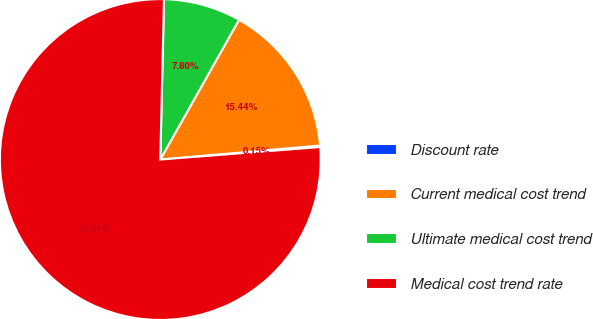Convert chart. <chart><loc_0><loc_0><loc_500><loc_500><pie_chart><fcel>Discount rate<fcel>Current medical cost trend<fcel>Ultimate medical cost trend<fcel>Medical cost trend rate<nl><fcel>0.15%<fcel>15.44%<fcel>7.8%<fcel>76.61%<nl></chart> 